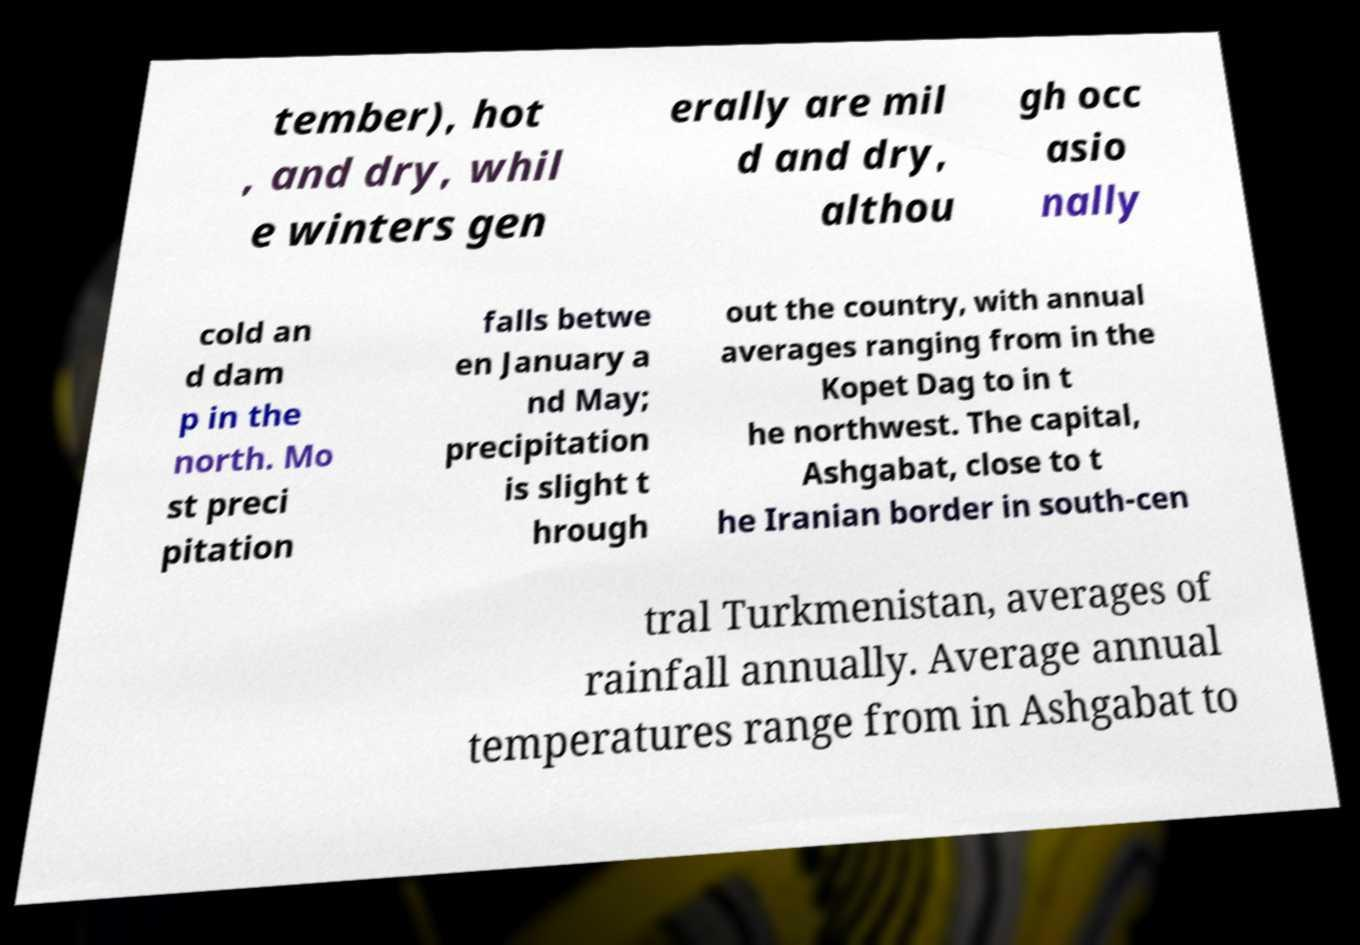Can you read and provide the text displayed in the image?This photo seems to have some interesting text. Can you extract and type it out for me? tember), hot , and dry, whil e winters gen erally are mil d and dry, althou gh occ asio nally cold an d dam p in the north. Mo st preci pitation falls betwe en January a nd May; precipitation is slight t hrough out the country, with annual averages ranging from in the Kopet Dag to in t he northwest. The capital, Ashgabat, close to t he Iranian border in south-cen tral Turkmenistan, averages of rainfall annually. Average annual temperatures range from in Ashgabat to 